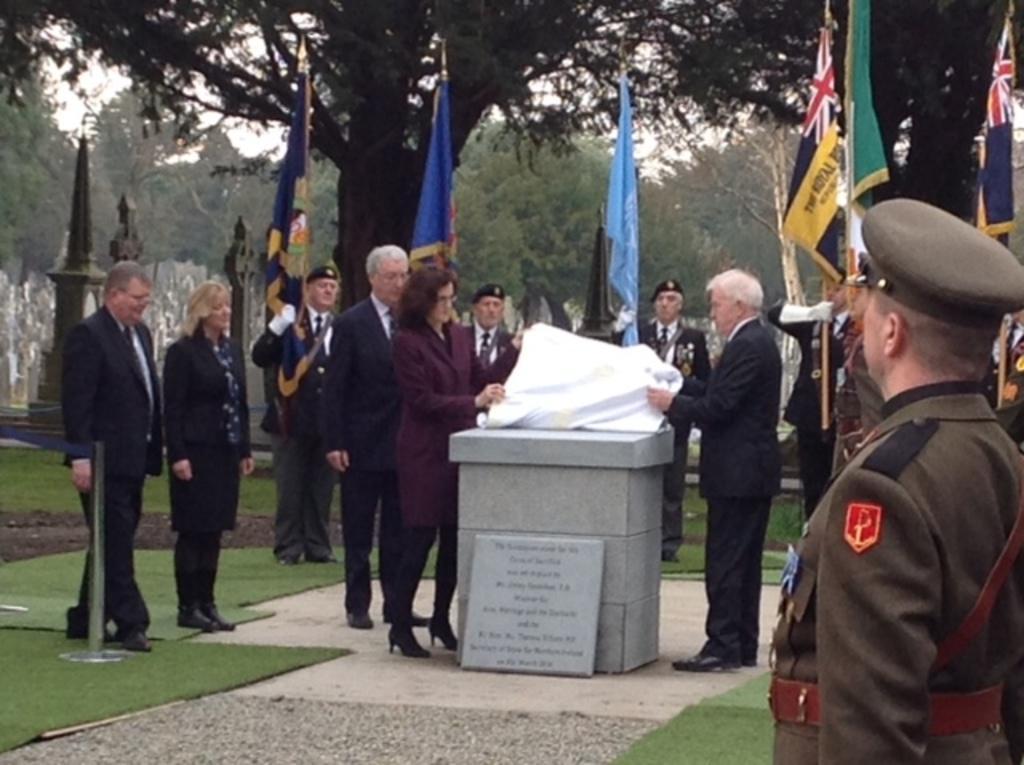Could you give a brief overview of what you see in this image? In the foreground of the picture there are people, flags, mats and a cornerstone. In the background there are trees and gravestones. Sky is cloudy. 